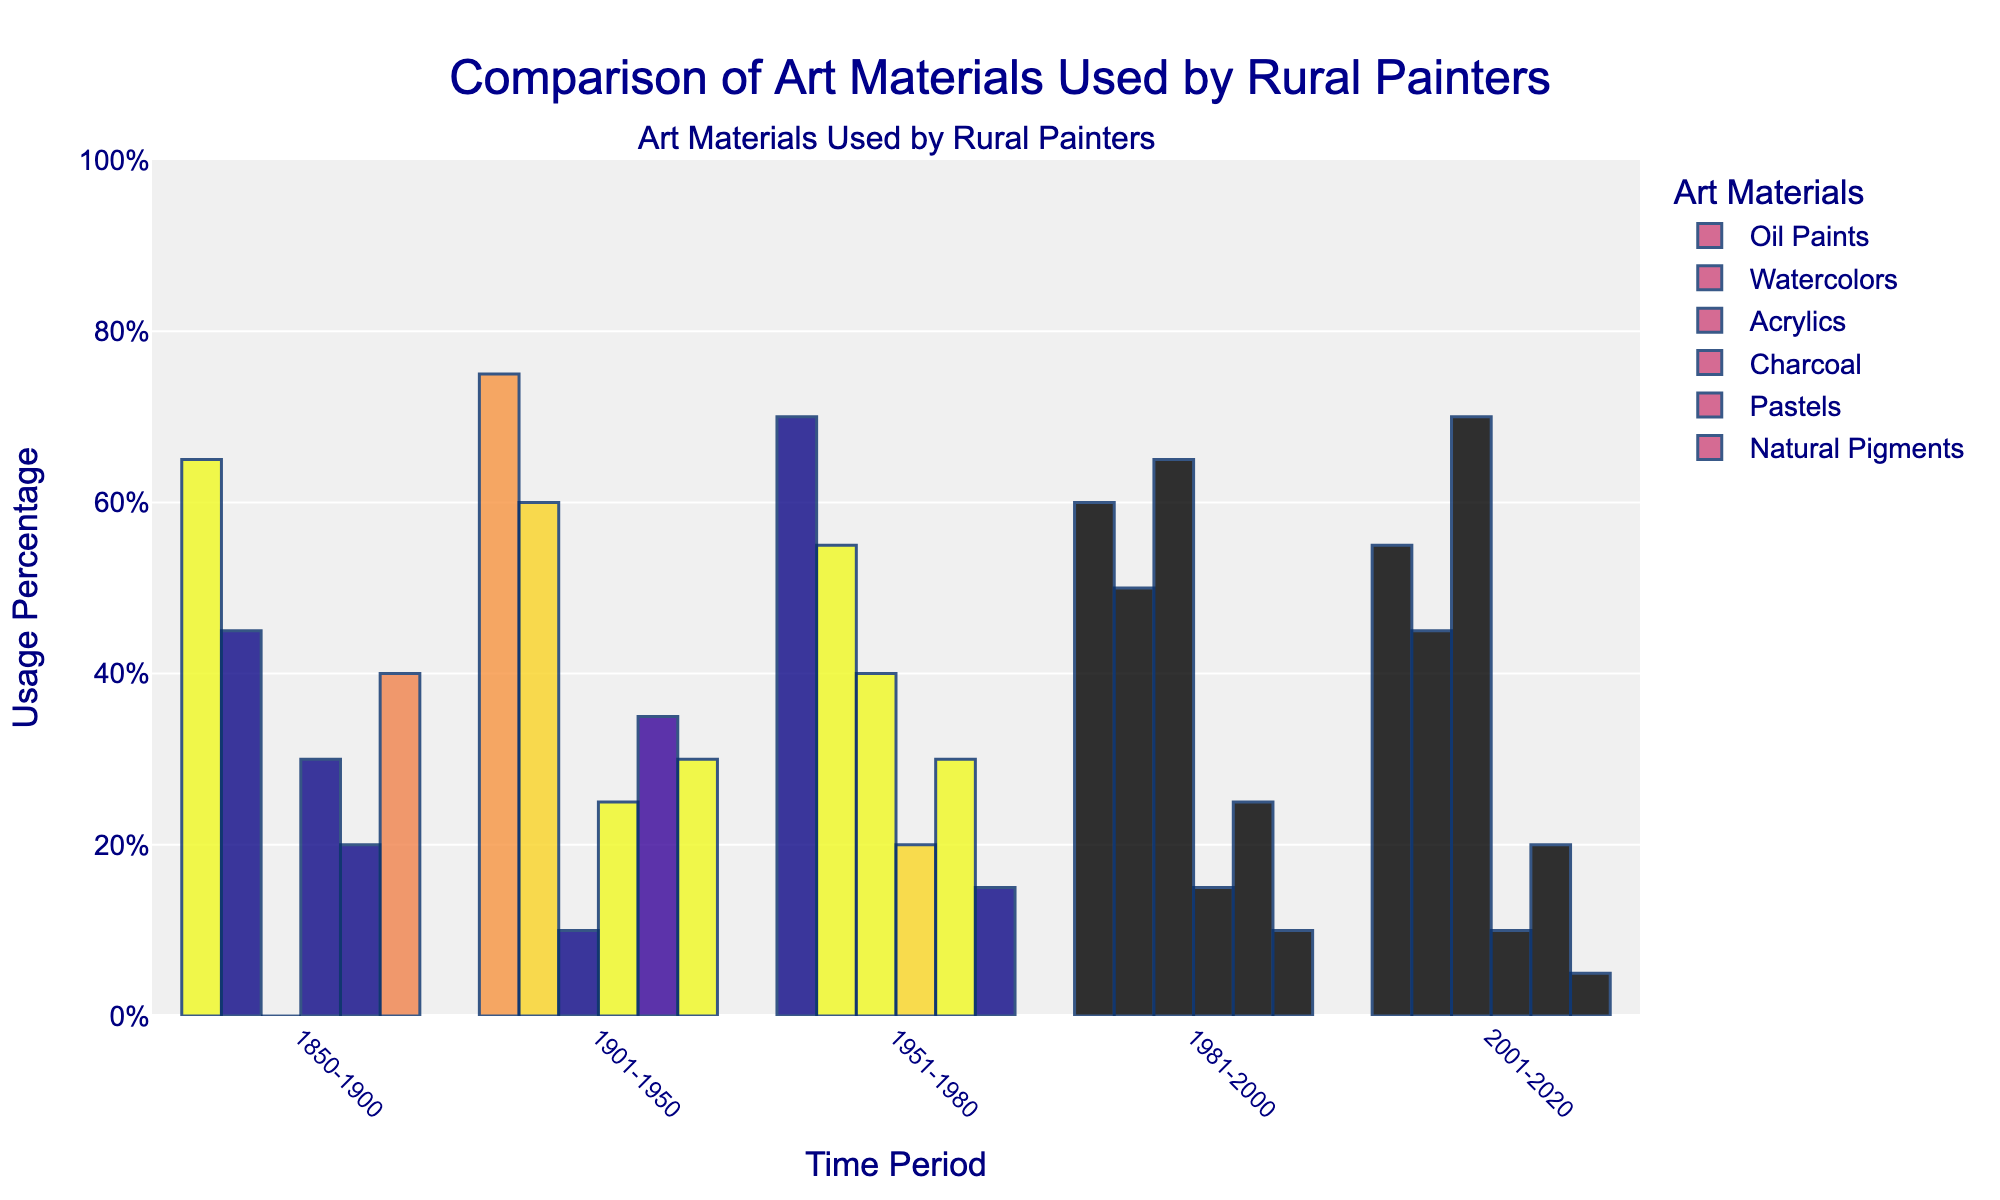Which time period saw the highest usage of natural pigments? The bar for natural pigments reaches its highest point in the 1850-1900 time period.
Answer: 1850-1900 Which material saw the biggest increase in usage from 1901-1950 to 1951-1980? The usage of acrylics increased from 10% in 1901-1950 to 40% in 1951-1980, a 30% increase.
Answer: Acrylics How did the usage of oil paints change from 1981-2000 to 2001-2020? The usage of oil paints decreased from 60% in 1981-2000 to 55% in 2001-2020, a 5% decline.
Answer: Decreased by 5% Is the usage of watercolors in 1850-1900 greater than the usage of pastels in the same period? The bar for watercolors in 1850-1900 is at 45%, while the bar for pastels is at 20%, thus, 45% is greater than 20%.
Answer: Yes What is the overall trend in the usage of charcoal from 1850 to 2020? The bar for charcoal gradually decreases over the time periods, from 30% in 1850-1900 to 10% in 2001-2020.
Answer: Decreasing Combine the usage of charcoal and natural pigments in 1951-1980. Does it exceed the usage of watercolors in the same period? The usage of charcoal (20%) and natural pigments (15%) combined is 35%, which is less than the usage of watercolors at 55%.
Answer: No What is the difference between the highest and lowest usage percentages of acrylics across all time periods? The highest usage of acrylics is 70% in 2001-2020, and the lowest is 0% in 1850-1900. The difference is 70% - 0% = 70%.
Answer: 70% During which time period did pastels see equal or greater usage than natural pigments? The usage of pastels is equal to or greater than natural pigments in the 1901-1950 (35% vs 30%) and 1951-1980 (30% vs 15%) periods.
Answer: 1901-1950 and 1951-1980 Which material's usage has continuously increased from 1850-1900 to 2001-2020? The bar for acrylics shows a continuous increase from 0% in 1850-1900 to 70% in 2001-2020.
Answer: Acrylics What is the average usage of watercolors over all time periods? Sum the usage percentages of watercolors for all periods (45 + 60 + 55 + 50 + 45 = 255) and divide by the number of periods (5). The average is 255 / 5 = 51%.
Answer: 51% 